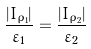Convert formula to latex. <formula><loc_0><loc_0><loc_500><loc_500>\frac { | I _ { \rho _ { 1 } } | } { \varepsilon _ { 1 } } & = \frac { | I _ { \rho _ { 2 } } | } { \varepsilon _ { 2 } }</formula> 